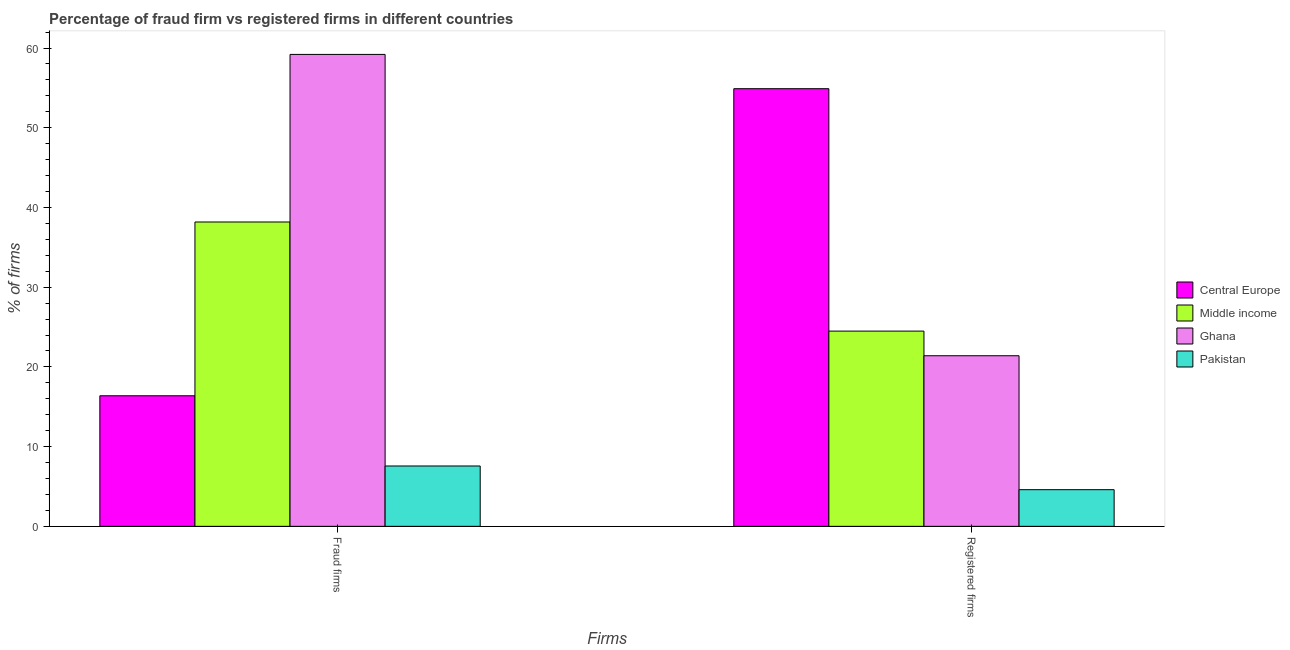How many groups of bars are there?
Provide a succinct answer. 2. Are the number of bars per tick equal to the number of legend labels?
Provide a short and direct response. Yes. Are the number of bars on each tick of the X-axis equal?
Offer a very short reply. Yes. How many bars are there on the 1st tick from the left?
Offer a terse response. 4. How many bars are there on the 2nd tick from the right?
Your answer should be compact. 4. What is the label of the 1st group of bars from the left?
Offer a very short reply. Fraud firms. What is the percentage of registered firms in Ghana?
Your answer should be very brief. 21.4. Across all countries, what is the maximum percentage of registered firms?
Your response must be concise. 54.9. Across all countries, what is the minimum percentage of fraud firms?
Keep it short and to the point. 7.57. What is the total percentage of registered firms in the graph?
Provide a succinct answer. 105.39. What is the difference between the percentage of registered firms in Central Europe and that in Pakistan?
Give a very brief answer. 50.3. What is the difference between the percentage of fraud firms in Pakistan and the percentage of registered firms in Ghana?
Keep it short and to the point. -13.83. What is the average percentage of fraud firms per country?
Make the answer very short. 30.33. What is the difference between the percentage of fraud firms and percentage of registered firms in Middle income?
Your answer should be compact. 13.69. In how many countries, is the percentage of fraud firms greater than 54 %?
Make the answer very short. 1. What is the ratio of the percentage of fraud firms in Central Europe to that in Middle income?
Make the answer very short. 0.43. In how many countries, is the percentage of fraud firms greater than the average percentage of fraud firms taken over all countries?
Keep it short and to the point. 2. Are the values on the major ticks of Y-axis written in scientific E-notation?
Your response must be concise. No. Does the graph contain any zero values?
Offer a terse response. No. Does the graph contain grids?
Keep it short and to the point. No. How are the legend labels stacked?
Offer a very short reply. Vertical. What is the title of the graph?
Provide a short and direct response. Percentage of fraud firm vs registered firms in different countries. What is the label or title of the X-axis?
Your answer should be very brief. Firms. What is the label or title of the Y-axis?
Give a very brief answer. % of firms. What is the % of firms in Central Europe in Fraud firms?
Your answer should be very brief. 16.38. What is the % of firms in Middle income in Fraud firms?
Offer a terse response. 38.18. What is the % of firms in Ghana in Fraud firms?
Make the answer very short. 59.2. What is the % of firms of Pakistan in Fraud firms?
Your answer should be compact. 7.57. What is the % of firms in Central Europe in Registered firms?
Keep it short and to the point. 54.9. What is the % of firms in Middle income in Registered firms?
Offer a terse response. 24.49. What is the % of firms in Ghana in Registered firms?
Offer a very short reply. 21.4. What is the % of firms in Pakistan in Registered firms?
Offer a terse response. 4.6. Across all Firms, what is the maximum % of firms in Central Europe?
Keep it short and to the point. 54.9. Across all Firms, what is the maximum % of firms in Middle income?
Your answer should be compact. 38.18. Across all Firms, what is the maximum % of firms of Ghana?
Your response must be concise. 59.2. Across all Firms, what is the maximum % of firms in Pakistan?
Your answer should be compact. 7.57. Across all Firms, what is the minimum % of firms of Central Europe?
Offer a terse response. 16.38. Across all Firms, what is the minimum % of firms of Middle income?
Your answer should be compact. 24.49. Across all Firms, what is the minimum % of firms in Ghana?
Your response must be concise. 21.4. Across all Firms, what is the minimum % of firms of Pakistan?
Provide a succinct answer. 4.6. What is the total % of firms of Central Europe in the graph?
Provide a succinct answer. 71.28. What is the total % of firms of Middle income in the graph?
Keep it short and to the point. 62.67. What is the total % of firms of Ghana in the graph?
Your answer should be compact. 80.6. What is the total % of firms of Pakistan in the graph?
Keep it short and to the point. 12.17. What is the difference between the % of firms in Central Europe in Fraud firms and that in Registered firms?
Your response must be concise. -38.52. What is the difference between the % of firms of Middle income in Fraud firms and that in Registered firms?
Keep it short and to the point. 13.69. What is the difference between the % of firms of Ghana in Fraud firms and that in Registered firms?
Your answer should be compact. 37.8. What is the difference between the % of firms in Pakistan in Fraud firms and that in Registered firms?
Keep it short and to the point. 2.97. What is the difference between the % of firms in Central Europe in Fraud firms and the % of firms in Middle income in Registered firms?
Your response must be concise. -8.11. What is the difference between the % of firms in Central Europe in Fraud firms and the % of firms in Ghana in Registered firms?
Ensure brevity in your answer.  -5.02. What is the difference between the % of firms of Central Europe in Fraud firms and the % of firms of Pakistan in Registered firms?
Offer a very short reply. 11.78. What is the difference between the % of firms in Middle income in Fraud firms and the % of firms in Ghana in Registered firms?
Offer a very short reply. 16.78. What is the difference between the % of firms in Middle income in Fraud firms and the % of firms in Pakistan in Registered firms?
Provide a succinct answer. 33.58. What is the difference between the % of firms of Ghana in Fraud firms and the % of firms of Pakistan in Registered firms?
Your answer should be very brief. 54.6. What is the average % of firms in Central Europe per Firms?
Your answer should be very brief. 35.64. What is the average % of firms of Middle income per Firms?
Give a very brief answer. 31.34. What is the average % of firms of Ghana per Firms?
Offer a very short reply. 40.3. What is the average % of firms in Pakistan per Firms?
Offer a very short reply. 6.08. What is the difference between the % of firms in Central Europe and % of firms in Middle income in Fraud firms?
Make the answer very short. -21.8. What is the difference between the % of firms in Central Europe and % of firms in Ghana in Fraud firms?
Make the answer very short. -42.82. What is the difference between the % of firms in Central Europe and % of firms in Pakistan in Fraud firms?
Your response must be concise. 8.81. What is the difference between the % of firms in Middle income and % of firms in Ghana in Fraud firms?
Make the answer very short. -21.02. What is the difference between the % of firms of Middle income and % of firms of Pakistan in Fraud firms?
Your answer should be compact. 30.61. What is the difference between the % of firms of Ghana and % of firms of Pakistan in Fraud firms?
Provide a succinct answer. 51.63. What is the difference between the % of firms of Central Europe and % of firms of Middle income in Registered firms?
Your answer should be compact. 30.41. What is the difference between the % of firms in Central Europe and % of firms in Ghana in Registered firms?
Give a very brief answer. 33.5. What is the difference between the % of firms in Central Europe and % of firms in Pakistan in Registered firms?
Give a very brief answer. 50.3. What is the difference between the % of firms in Middle income and % of firms in Ghana in Registered firms?
Keep it short and to the point. 3.09. What is the difference between the % of firms of Middle income and % of firms of Pakistan in Registered firms?
Your answer should be compact. 19.89. What is the difference between the % of firms of Ghana and % of firms of Pakistan in Registered firms?
Offer a terse response. 16.8. What is the ratio of the % of firms of Central Europe in Fraud firms to that in Registered firms?
Provide a short and direct response. 0.3. What is the ratio of the % of firms of Middle income in Fraud firms to that in Registered firms?
Provide a short and direct response. 1.56. What is the ratio of the % of firms of Ghana in Fraud firms to that in Registered firms?
Your answer should be compact. 2.77. What is the ratio of the % of firms in Pakistan in Fraud firms to that in Registered firms?
Your answer should be compact. 1.65. What is the difference between the highest and the second highest % of firms in Central Europe?
Offer a very short reply. 38.52. What is the difference between the highest and the second highest % of firms in Middle income?
Offer a very short reply. 13.69. What is the difference between the highest and the second highest % of firms in Ghana?
Provide a succinct answer. 37.8. What is the difference between the highest and the second highest % of firms in Pakistan?
Give a very brief answer. 2.97. What is the difference between the highest and the lowest % of firms of Central Europe?
Your answer should be compact. 38.52. What is the difference between the highest and the lowest % of firms of Middle income?
Make the answer very short. 13.69. What is the difference between the highest and the lowest % of firms in Ghana?
Give a very brief answer. 37.8. What is the difference between the highest and the lowest % of firms in Pakistan?
Your answer should be compact. 2.97. 